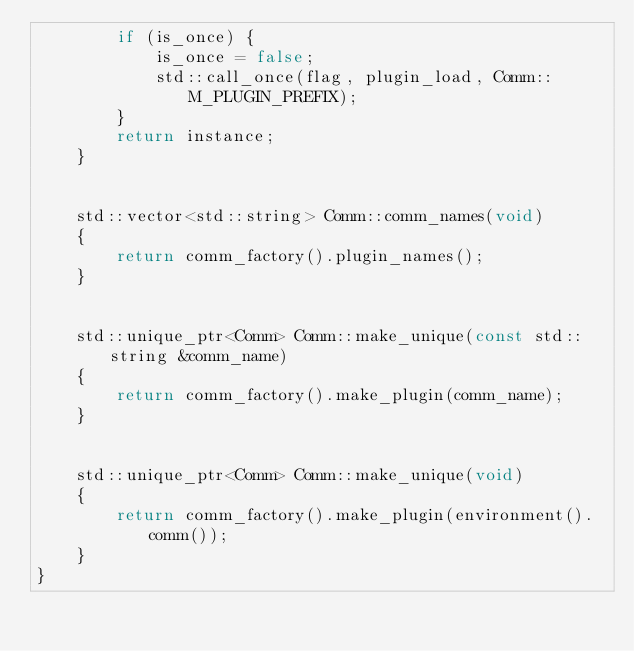<code> <loc_0><loc_0><loc_500><loc_500><_C++_>        if (is_once) {
            is_once = false;
            std::call_once(flag, plugin_load, Comm::M_PLUGIN_PREFIX);
        }
        return instance;
    }


    std::vector<std::string> Comm::comm_names(void)
    {
        return comm_factory().plugin_names();
    }


    std::unique_ptr<Comm> Comm::make_unique(const std::string &comm_name)
    {
        return comm_factory().make_plugin(comm_name);
    }


    std::unique_ptr<Comm> Comm::make_unique(void)
    {
        return comm_factory().make_plugin(environment().comm());
    }
}
</code> 